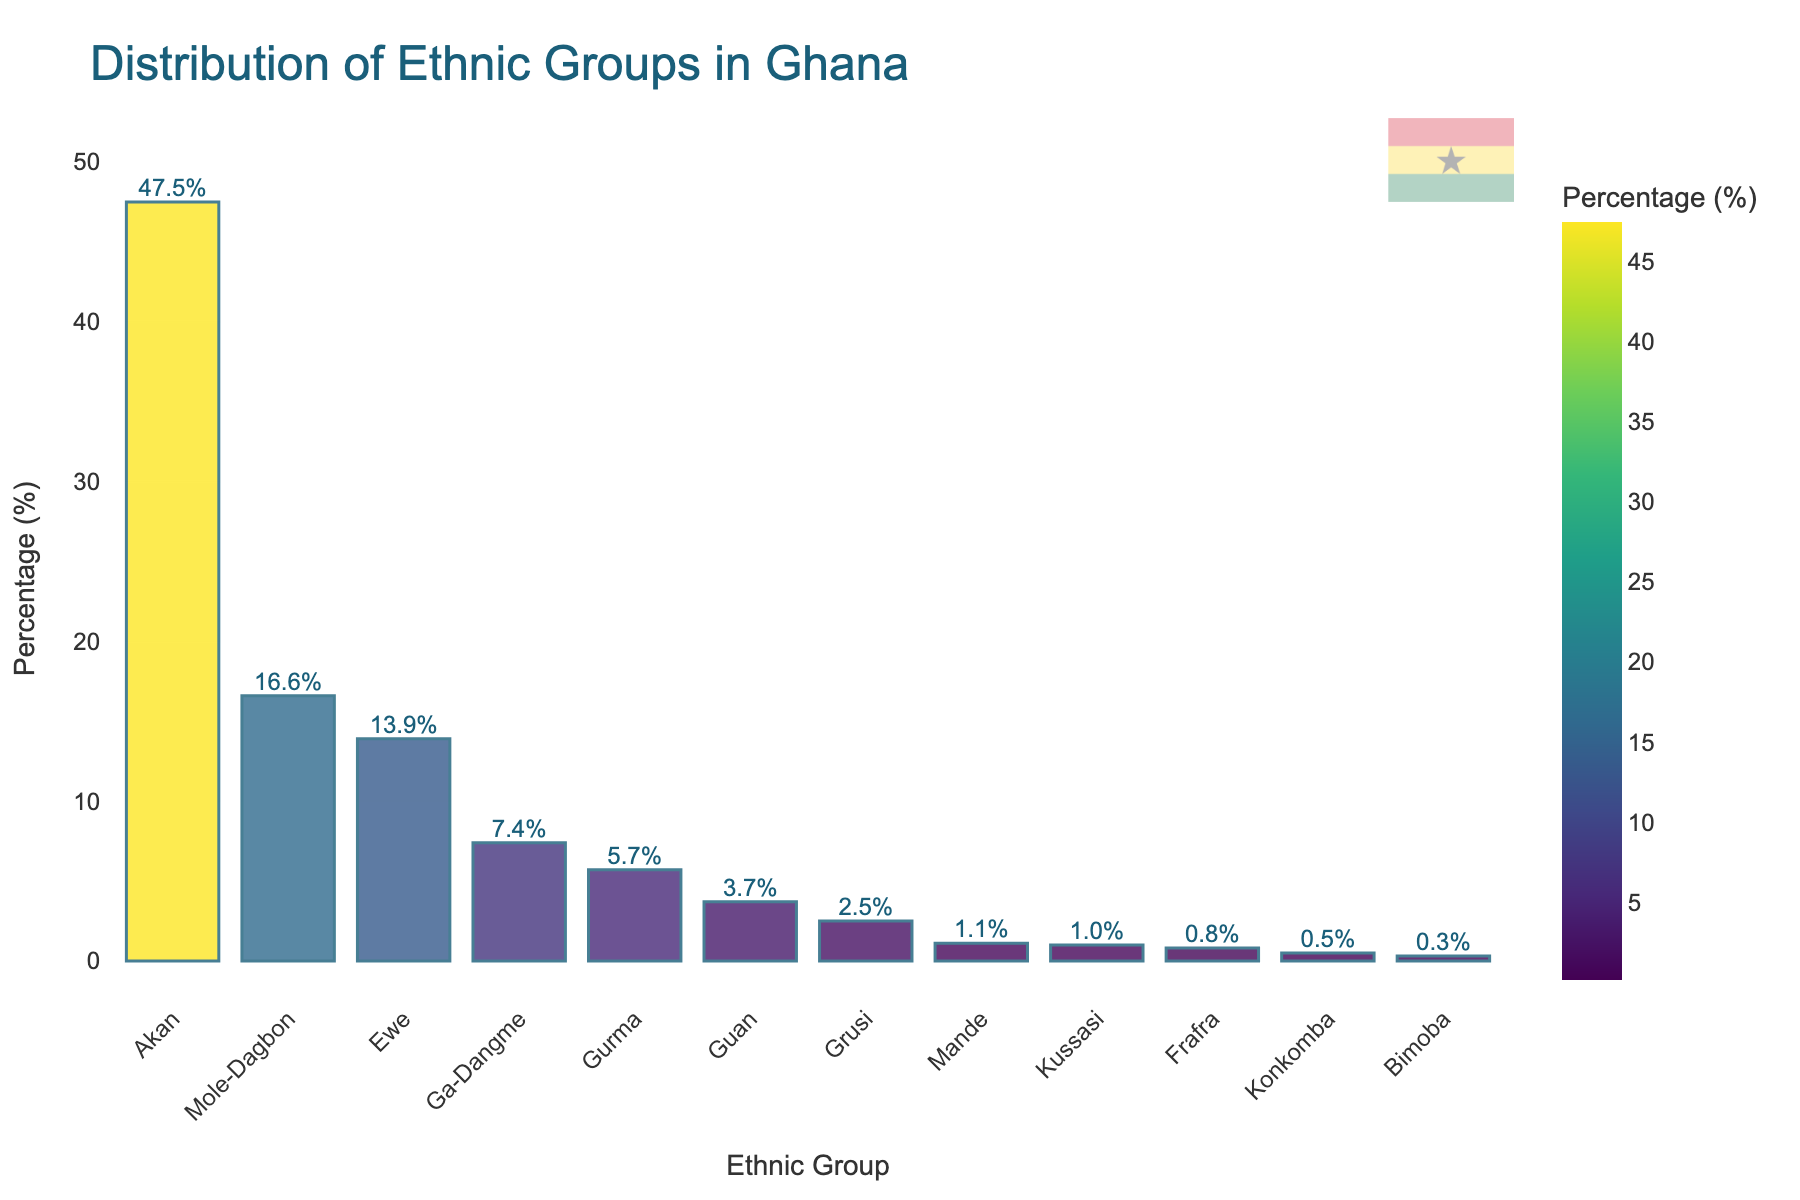Which ethnic group has the highest representation in the Ghanaian population? The bar chart shows the distribution of ethnic groups in Ghana, with the Akan group having the highest percentage.
Answer: Akan What is the combined percentage of the Mole-Dagbon, Ewe, and Ga-Dangme groups? By summing the percentages of Mole-Dagbon (16.6%), Ewe (13.9%), and Ga-Dangme (7.4%): 16.6% + 13.9% + 7.4% = 37.9%.
Answer: 37.9% Which ethnic group has a slightly higher representation: Kussasi or Frafra? Comparing the heights of the bars, Kussasi has a percentage of 1.0%, while Frafra has a percentage of 0.8%.
Answer: Kussasi What is the percentage difference between the Akan and Mole-Dagbon groups? The Akan group has a percentage of 47.5%, and the Mole-Dagbon group has 16.6%. The difference is 47.5% - 16.6% = 30.9%.
Answer: 30.9% Which ethnic group constitutes less than 1% of the population? The chart indicates that the Mande, Kussasi, Frafra, Konkomba, and Bimoba groups each have less than 1% representation.
Answer: Mande, Kussasi, Frafra, Konkomba, Bimoba How much more does the Ga-Dangme group represent compared to the Guan group? The percentage of the Ga-Dangme group is 7.4%, and that of the Guan group is 3.7%. The difference is 7.4% - 3.7% = 3.7%.
Answer: 3.7% What's the cumulative percentage of the three smallest ethnic groups? The Bimoba (0.3%), Konkomba (0.5%), and Frafra (0.8%) groups together make 0.3% + 0.5% + 0.8% = 1.6%.
Answer: 1.6% Which color shade represents the Akan group and why? The Akan group, having the highest percentage, is shown in the darkest shade of the Viridis color scale used in the chart.
Answer: Darkest shade of Viridis How many ethnic groups have more than 10% representation? The bar chart shows that Akan, Mole-Dagbon, and Ewe groups have more than 10% representation each.
Answer: 3 